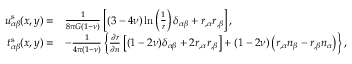<formula> <loc_0><loc_0><loc_500><loc_500>\begin{array} { r l } { u _ { \alpha \beta } ^ { s } ( x , y ) = } & { \frac { 1 } { 8 \pi G ( 1 - \nu ) } \left [ ( 3 - 4 \nu ) \ln \left ( \frac { 1 } { r } \right ) \delta _ { \alpha \beta } + r _ { , \alpha } r _ { , \beta } \right ] , } \\ { t _ { \alpha \beta } ^ { s } ( x , y ) = } & { - \frac { 1 } { 4 \pi ( 1 - \nu ) } \left \{ \frac { \partial r } { \partial n } \left [ ( 1 - 2 \nu ) \delta _ { \alpha \beta } + 2 r _ { , \alpha } r _ { , \beta } \right ] + ( 1 - 2 \nu ) \left ( r _ { , \alpha } n _ { \beta } - r _ { , \beta } n _ { \alpha } \right ) \right \} , } \end{array}</formula> 